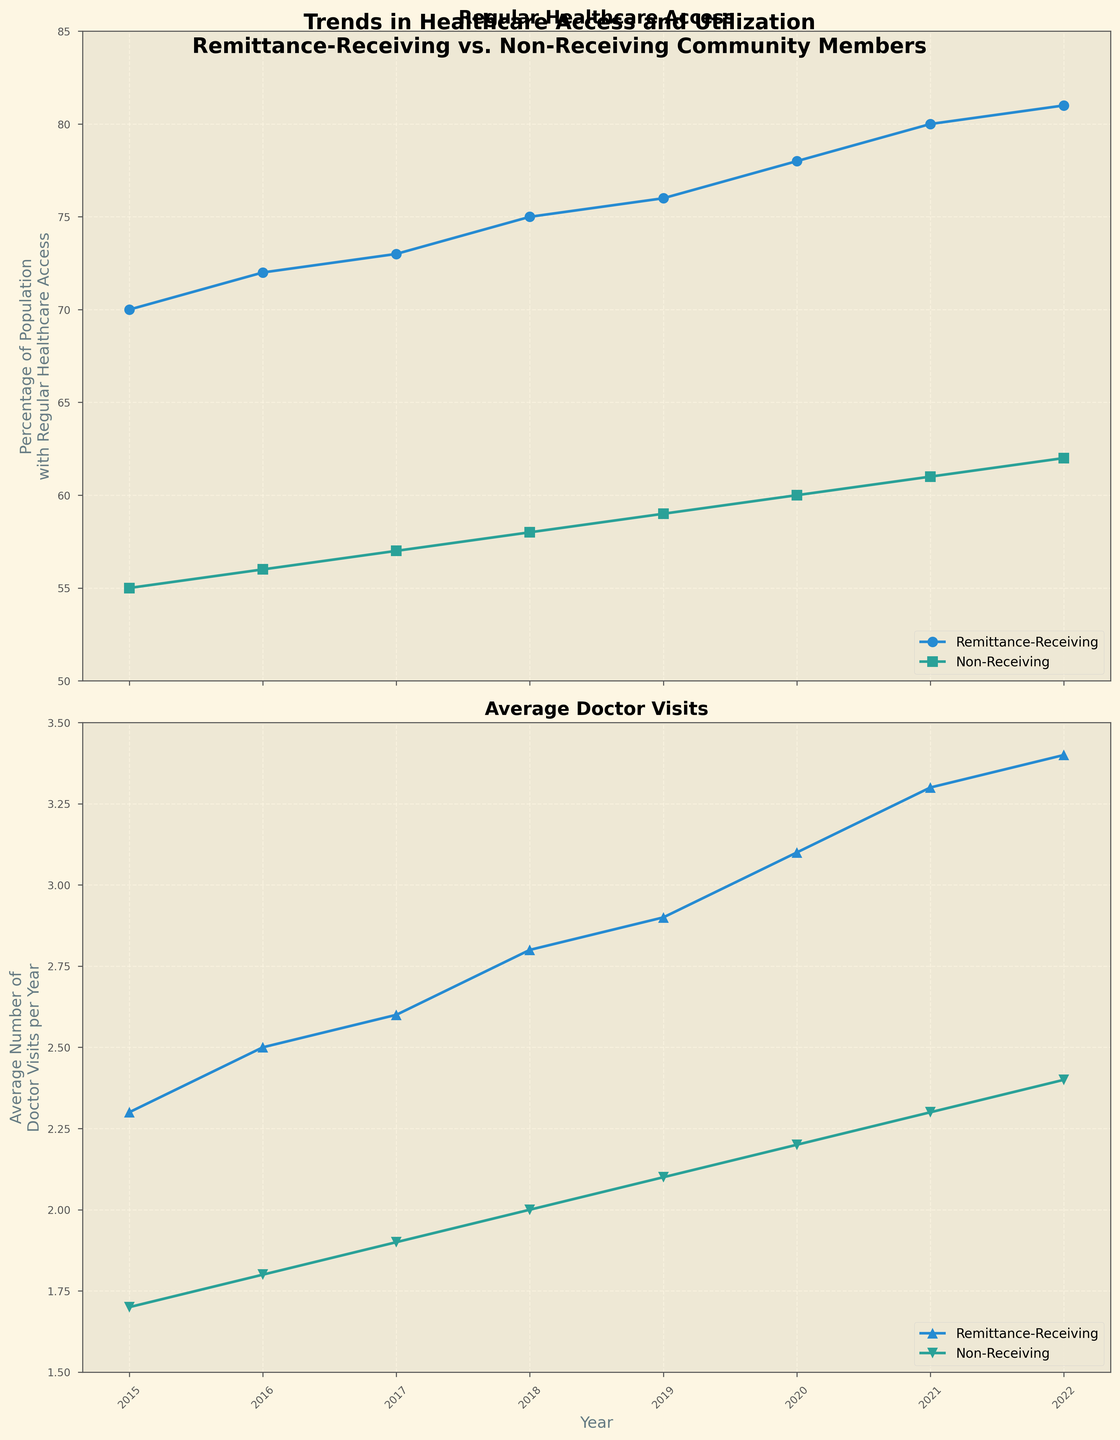What is the title of the plot? The title of a plot is usually found at the top and provides a summary of what the plot depicts. In this case, it reads 'Trends in Healthcare Access and Utilization Remittance-Receiving vs. Non-Receiving Community Members'.
Answer: Trends in Healthcare Access and Utilization Remittance-Receiving vs. Non-Receiving Community Members What was the percentage of the population with regular healthcare access for remittance-receiving members in 2021? Look at the first subplot and find the data point for remittance-receiving members in 2021. The marker for this group is 'o', and it aligns with 80% on the y-axis.
Answer: 80% How did the average number of doctor visits per year change for non-receiving members from 2015 to 2022? Look at the second subplot. The markers for non-receiving members are 'v'. Find the data points for 2015 and 2022 and note the change in the y-values, which is from 1.7 to 2.4.
Answer: Increased by 0.7 Which year saw the greatest percentage increase in regular healthcare access for remittance-receiving members? Identify the year-by-year differences for remittance-receiving members in the first plot, then find the year with the largest percentage increase. The greatest increase happened from 2020 (78%) to 2021 (80%), which is a 2% increase.
Answer: 2020 to 2021 Compare the average number of doctor visits per year between remittance-receiving and non-receiving members in 2020. Which group had more visits? Look at the second subplot for 2020. The remittance-receiving group had 3.1 visits, while the non-receiving group had 2.2 visits.
Answer: Remittance-receiving What was the overall trend for the percentage of the population with regular healthcare access among non-receiving members from 2015 to 2022? Look at the trend line in the first subplot for non-receiving members. The percentage steadily increases from 55% in 2015 to 62% in 2022.
Answer: Increasing trend In which year did the remittance-receiving community have a 75% population with regular healthcare access? Referring to the first subplot, the data point for remittance-receiving members at 75% is in 2018.
Answer: 2018 What is the general shape of the trend line for the average number of doctor visits per year for remittance-receiving members? In the second subplot, the trend line for remittance-receiving members steadily increases from 2.3 in 2015 to 3.4 in 2022, forming an upward trend.
Answer: Upward trend What is the difference in the average number of doctor visits per year between remittance-receiving and non-receiving members in 2017? From the second subplot, remittance-receiving members had 2.6 visits, and non-receiving members had 1.9 visits. The difference is 2.6 - 1.9.
Answer: 0.7 Did the gap in regular healthcare access between remittance-receiving and non-receiving members grow or shrink from 2015 to 2022? Calculate the gap for both years: 
In 2015, the gap was 70% - 55% = 15%. 
In 2022, the gap was 81% - 62% = 19%. 
Since 19% > 15%, the gap grew.
Answer: Grew 